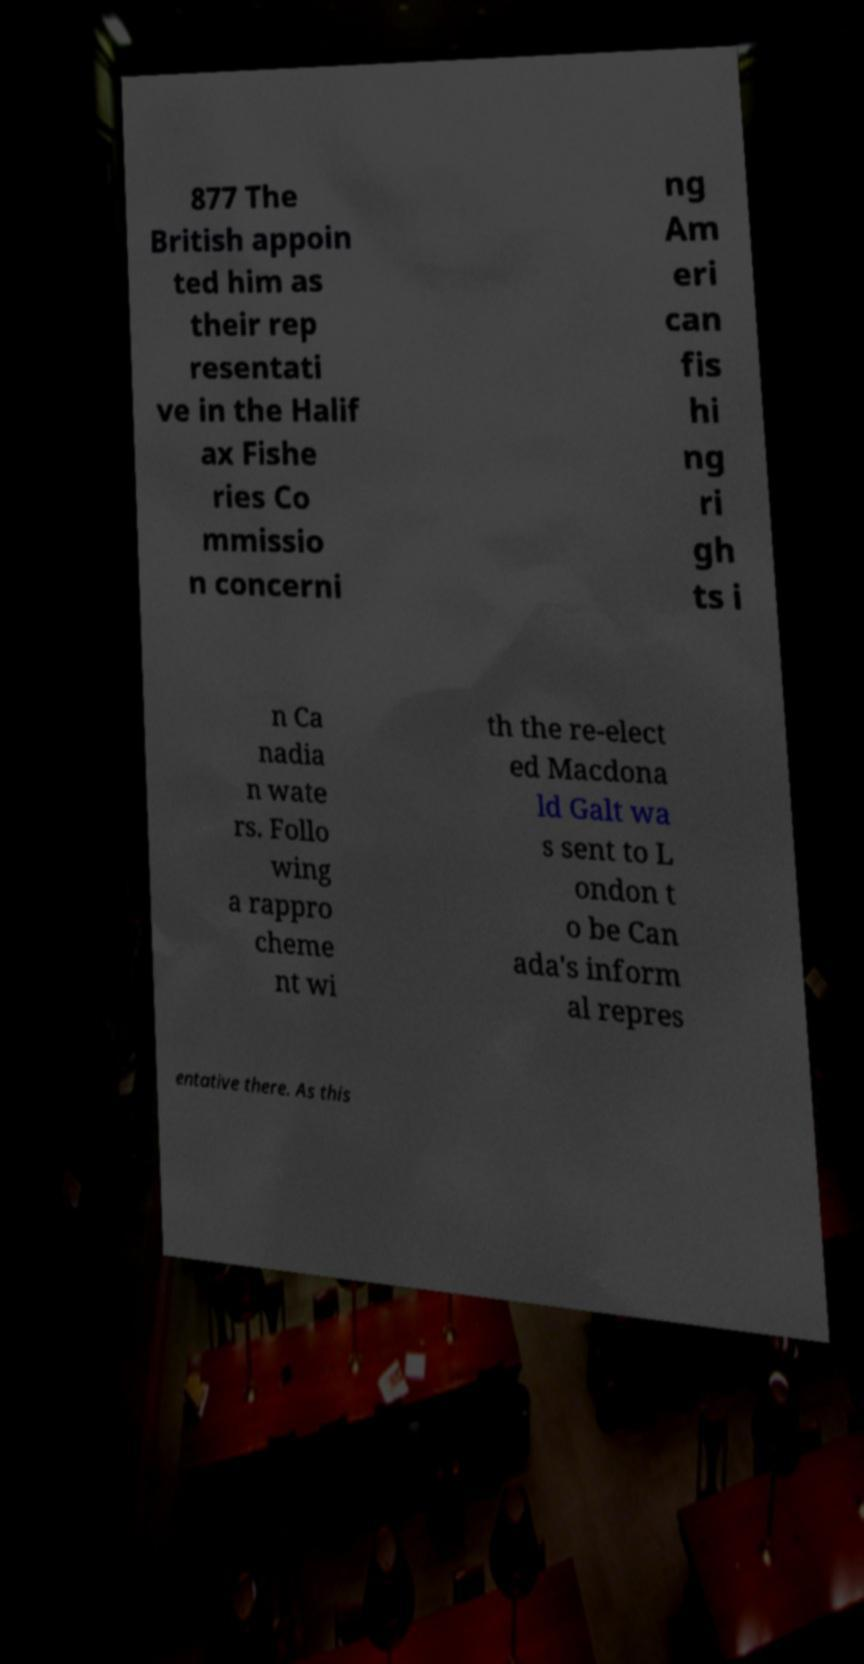Please identify and transcribe the text found in this image. 877 The British appoin ted him as their rep resentati ve in the Halif ax Fishe ries Co mmissio n concerni ng Am eri can fis hi ng ri gh ts i n Ca nadia n wate rs. Follo wing a rappro cheme nt wi th the re-elect ed Macdona ld Galt wa s sent to L ondon t o be Can ada's inform al repres entative there. As this 